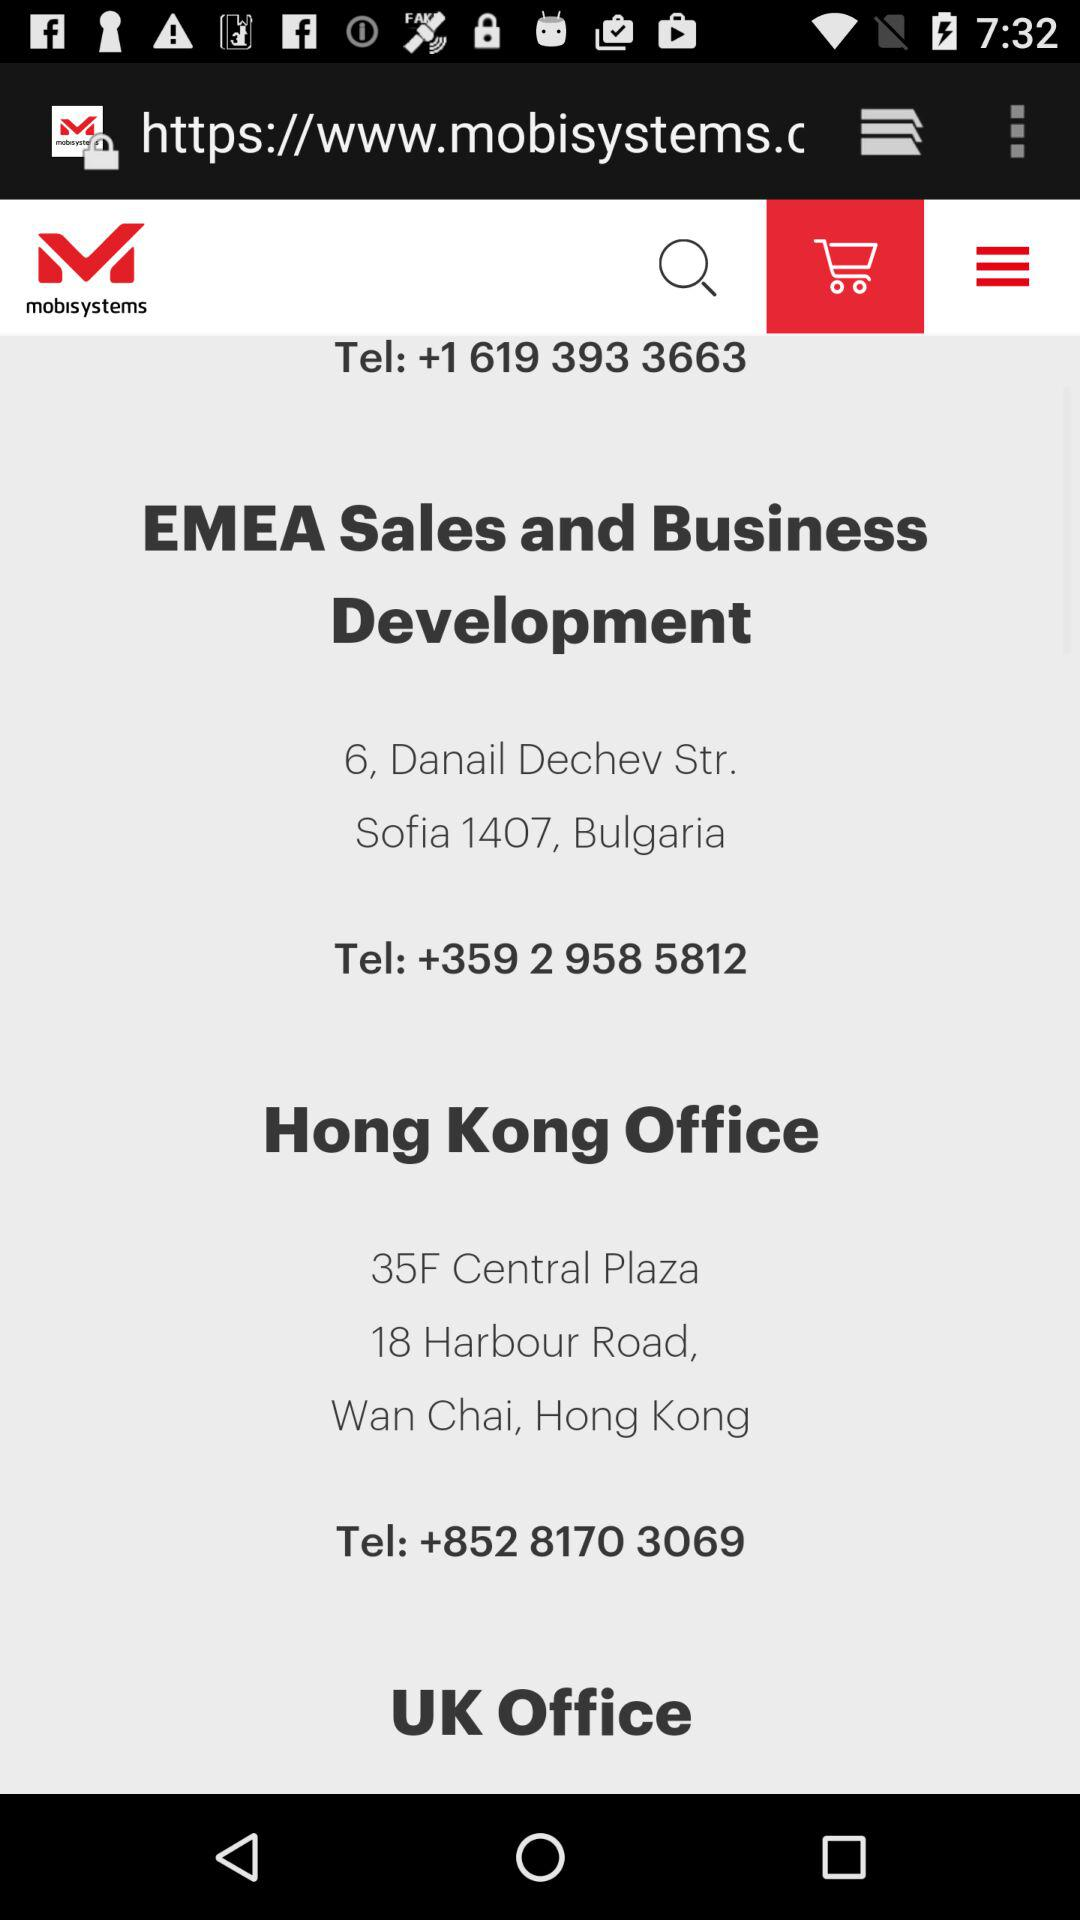What is the address of "EMEA Sales and Business Development"? The address is 6, Danail Dechev Str. Sofia 1407, Bulgaria. 